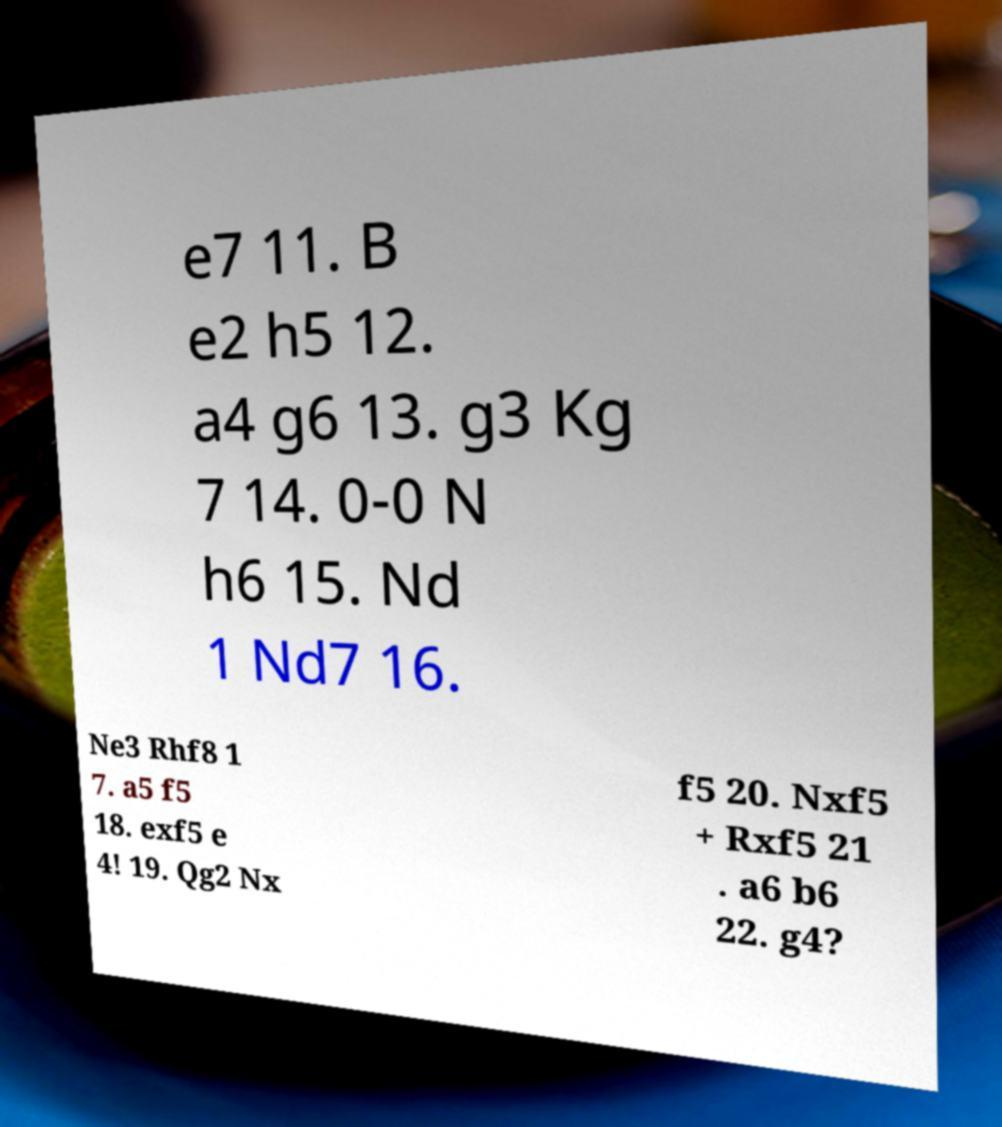There's text embedded in this image that I need extracted. Can you transcribe it verbatim? e7 11. B e2 h5 12. a4 g6 13. g3 Kg 7 14. 0-0 N h6 15. Nd 1 Nd7 16. Ne3 Rhf8 1 7. a5 f5 18. exf5 e 4! 19. Qg2 Nx f5 20. Nxf5 + Rxf5 21 . a6 b6 22. g4? 